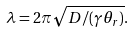<formula> <loc_0><loc_0><loc_500><loc_500>\lambda = 2 \pi \sqrt { D / ( \gamma \theta _ { r } ) } .</formula> 